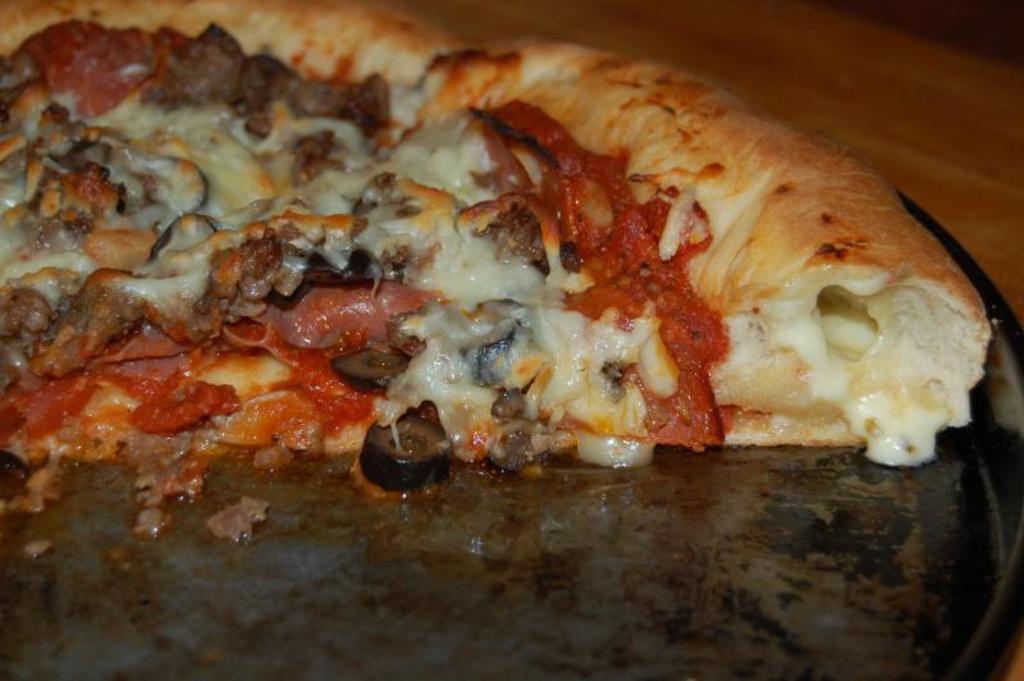Can you describe this image briefly? In this image we can see pizza places on the serving plate. 